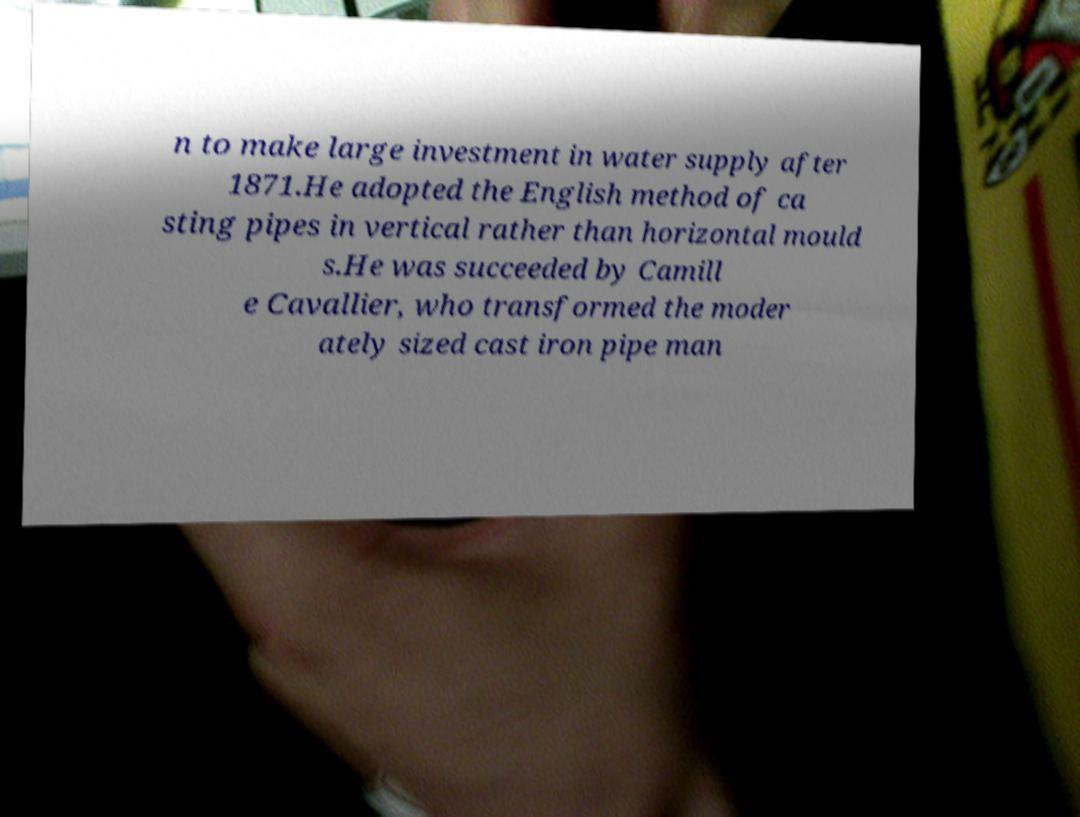Please identify and transcribe the text found in this image. n to make large investment in water supply after 1871.He adopted the English method of ca sting pipes in vertical rather than horizontal mould s.He was succeeded by Camill e Cavallier, who transformed the moder ately sized cast iron pipe man 